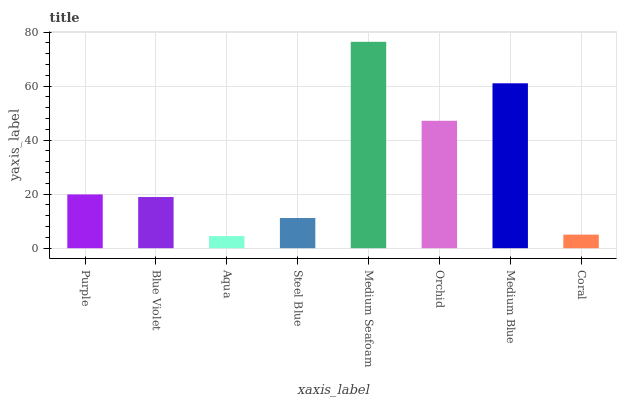Is Aqua the minimum?
Answer yes or no. Yes. Is Medium Seafoam the maximum?
Answer yes or no. Yes. Is Blue Violet the minimum?
Answer yes or no. No. Is Blue Violet the maximum?
Answer yes or no. No. Is Purple greater than Blue Violet?
Answer yes or no. Yes. Is Blue Violet less than Purple?
Answer yes or no. Yes. Is Blue Violet greater than Purple?
Answer yes or no. No. Is Purple less than Blue Violet?
Answer yes or no. No. Is Purple the high median?
Answer yes or no. Yes. Is Blue Violet the low median?
Answer yes or no. Yes. Is Medium Seafoam the high median?
Answer yes or no. No. Is Purple the low median?
Answer yes or no. No. 